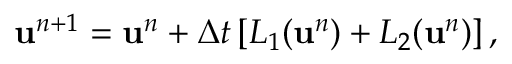Convert formula to latex. <formula><loc_0><loc_0><loc_500><loc_500>u ^ { n + 1 } = u ^ { n } + \Delta t \left [ L _ { 1 } ( u ^ { n } ) + L _ { 2 } ( u ^ { n } ) \right ] ,</formula> 